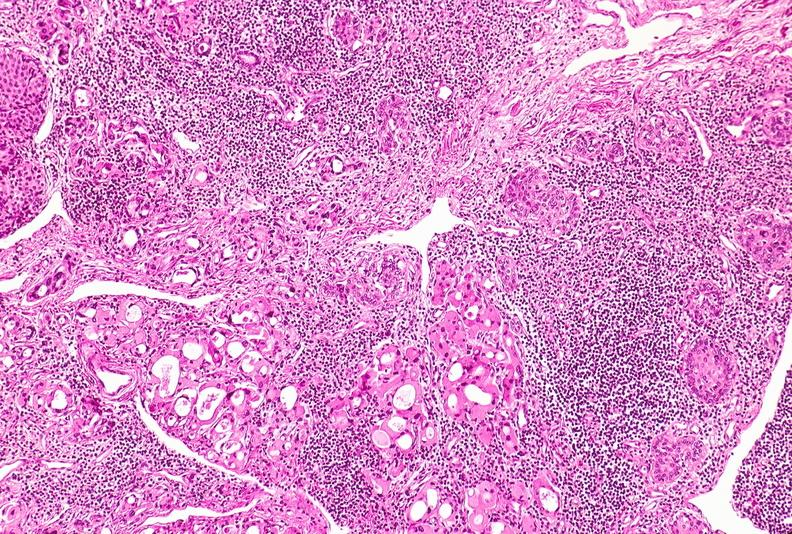s endocrine present?
Answer the question using a single word or phrase. Yes 